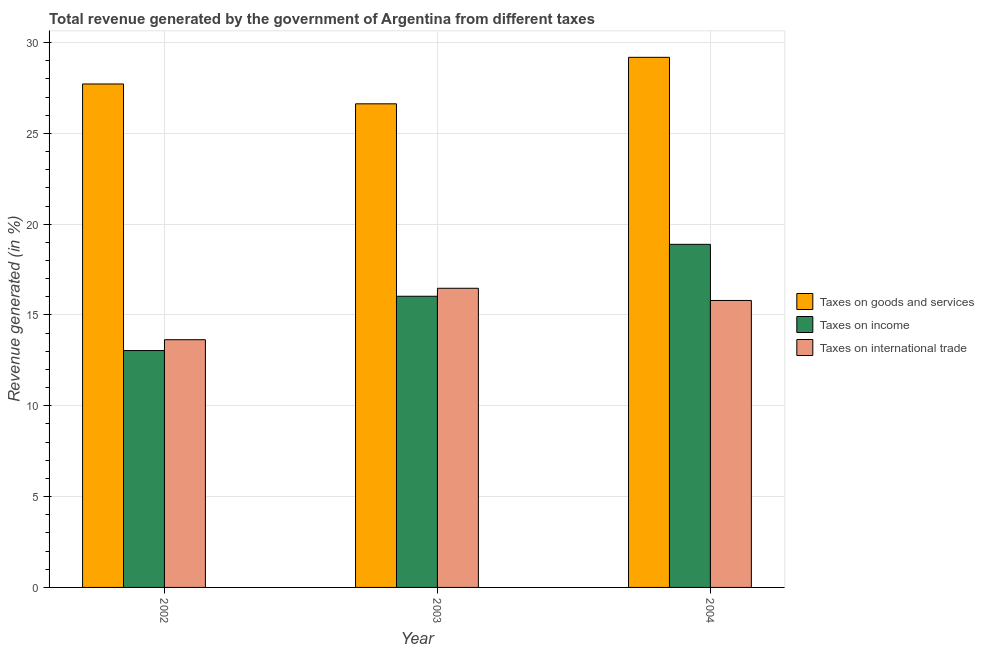How many groups of bars are there?
Keep it short and to the point. 3. What is the percentage of revenue generated by taxes on income in 2003?
Give a very brief answer. 16.03. Across all years, what is the maximum percentage of revenue generated by taxes on goods and services?
Ensure brevity in your answer.  29.19. Across all years, what is the minimum percentage of revenue generated by taxes on goods and services?
Offer a terse response. 26.63. In which year was the percentage of revenue generated by tax on international trade maximum?
Provide a succinct answer. 2003. What is the total percentage of revenue generated by taxes on goods and services in the graph?
Give a very brief answer. 83.53. What is the difference between the percentage of revenue generated by tax on international trade in 2003 and that in 2004?
Make the answer very short. 0.67. What is the difference between the percentage of revenue generated by tax on international trade in 2003 and the percentage of revenue generated by taxes on income in 2002?
Your answer should be very brief. 2.83. What is the average percentage of revenue generated by taxes on goods and services per year?
Provide a succinct answer. 27.84. In how many years, is the percentage of revenue generated by taxes on goods and services greater than 14 %?
Your answer should be compact. 3. What is the ratio of the percentage of revenue generated by taxes on goods and services in 2002 to that in 2003?
Offer a very short reply. 1.04. Is the percentage of revenue generated by taxes on income in 2002 less than that in 2004?
Offer a terse response. Yes. Is the difference between the percentage of revenue generated by taxes on income in 2003 and 2004 greater than the difference between the percentage of revenue generated by tax on international trade in 2003 and 2004?
Your answer should be very brief. No. What is the difference between the highest and the second highest percentage of revenue generated by taxes on goods and services?
Offer a terse response. 1.47. What is the difference between the highest and the lowest percentage of revenue generated by taxes on income?
Your answer should be very brief. 5.85. In how many years, is the percentage of revenue generated by tax on international trade greater than the average percentage of revenue generated by tax on international trade taken over all years?
Ensure brevity in your answer.  2. Is the sum of the percentage of revenue generated by taxes on income in 2002 and 2004 greater than the maximum percentage of revenue generated by taxes on goods and services across all years?
Provide a short and direct response. Yes. What does the 3rd bar from the left in 2004 represents?
Your response must be concise. Taxes on international trade. What does the 3rd bar from the right in 2002 represents?
Give a very brief answer. Taxes on goods and services. Is it the case that in every year, the sum of the percentage of revenue generated by taxes on goods and services and percentage of revenue generated by taxes on income is greater than the percentage of revenue generated by tax on international trade?
Your answer should be very brief. Yes. How many bars are there?
Make the answer very short. 9. Are all the bars in the graph horizontal?
Offer a terse response. No. How many years are there in the graph?
Keep it short and to the point. 3. Are the values on the major ticks of Y-axis written in scientific E-notation?
Give a very brief answer. No. What is the title of the graph?
Ensure brevity in your answer.  Total revenue generated by the government of Argentina from different taxes. What is the label or title of the X-axis?
Ensure brevity in your answer.  Year. What is the label or title of the Y-axis?
Keep it short and to the point. Revenue generated (in %). What is the Revenue generated (in %) in Taxes on goods and services in 2002?
Provide a short and direct response. 27.72. What is the Revenue generated (in %) in Taxes on income in 2002?
Provide a succinct answer. 13.04. What is the Revenue generated (in %) in Taxes on international trade in 2002?
Your response must be concise. 13.64. What is the Revenue generated (in %) in Taxes on goods and services in 2003?
Ensure brevity in your answer.  26.63. What is the Revenue generated (in %) of Taxes on income in 2003?
Offer a very short reply. 16.03. What is the Revenue generated (in %) in Taxes on international trade in 2003?
Your response must be concise. 16.47. What is the Revenue generated (in %) in Taxes on goods and services in 2004?
Your answer should be compact. 29.19. What is the Revenue generated (in %) in Taxes on income in 2004?
Your answer should be very brief. 18.89. What is the Revenue generated (in %) in Taxes on international trade in 2004?
Your response must be concise. 15.8. Across all years, what is the maximum Revenue generated (in %) of Taxes on goods and services?
Your response must be concise. 29.19. Across all years, what is the maximum Revenue generated (in %) of Taxes on income?
Offer a terse response. 18.89. Across all years, what is the maximum Revenue generated (in %) of Taxes on international trade?
Provide a succinct answer. 16.47. Across all years, what is the minimum Revenue generated (in %) in Taxes on goods and services?
Keep it short and to the point. 26.63. Across all years, what is the minimum Revenue generated (in %) in Taxes on income?
Make the answer very short. 13.04. Across all years, what is the minimum Revenue generated (in %) of Taxes on international trade?
Your answer should be compact. 13.64. What is the total Revenue generated (in %) of Taxes on goods and services in the graph?
Your answer should be compact. 83.53. What is the total Revenue generated (in %) in Taxes on income in the graph?
Keep it short and to the point. 47.96. What is the total Revenue generated (in %) of Taxes on international trade in the graph?
Provide a short and direct response. 45.91. What is the difference between the Revenue generated (in %) in Taxes on goods and services in 2002 and that in 2003?
Make the answer very short. 1.09. What is the difference between the Revenue generated (in %) of Taxes on income in 2002 and that in 2003?
Your response must be concise. -2.99. What is the difference between the Revenue generated (in %) of Taxes on international trade in 2002 and that in 2003?
Offer a terse response. -2.83. What is the difference between the Revenue generated (in %) in Taxes on goods and services in 2002 and that in 2004?
Your response must be concise. -1.47. What is the difference between the Revenue generated (in %) of Taxes on income in 2002 and that in 2004?
Your response must be concise. -5.85. What is the difference between the Revenue generated (in %) in Taxes on international trade in 2002 and that in 2004?
Your response must be concise. -2.16. What is the difference between the Revenue generated (in %) in Taxes on goods and services in 2003 and that in 2004?
Keep it short and to the point. -2.56. What is the difference between the Revenue generated (in %) in Taxes on income in 2003 and that in 2004?
Keep it short and to the point. -2.86. What is the difference between the Revenue generated (in %) of Taxes on international trade in 2003 and that in 2004?
Keep it short and to the point. 0.67. What is the difference between the Revenue generated (in %) in Taxes on goods and services in 2002 and the Revenue generated (in %) in Taxes on income in 2003?
Give a very brief answer. 11.69. What is the difference between the Revenue generated (in %) of Taxes on goods and services in 2002 and the Revenue generated (in %) of Taxes on international trade in 2003?
Your answer should be very brief. 11.25. What is the difference between the Revenue generated (in %) in Taxes on income in 2002 and the Revenue generated (in %) in Taxes on international trade in 2003?
Give a very brief answer. -3.43. What is the difference between the Revenue generated (in %) in Taxes on goods and services in 2002 and the Revenue generated (in %) in Taxes on income in 2004?
Keep it short and to the point. 8.83. What is the difference between the Revenue generated (in %) of Taxes on goods and services in 2002 and the Revenue generated (in %) of Taxes on international trade in 2004?
Ensure brevity in your answer.  11.92. What is the difference between the Revenue generated (in %) in Taxes on income in 2002 and the Revenue generated (in %) in Taxes on international trade in 2004?
Your answer should be compact. -2.76. What is the difference between the Revenue generated (in %) in Taxes on goods and services in 2003 and the Revenue generated (in %) in Taxes on income in 2004?
Your response must be concise. 7.74. What is the difference between the Revenue generated (in %) in Taxes on goods and services in 2003 and the Revenue generated (in %) in Taxes on international trade in 2004?
Offer a terse response. 10.83. What is the difference between the Revenue generated (in %) in Taxes on income in 2003 and the Revenue generated (in %) in Taxes on international trade in 2004?
Your answer should be compact. 0.23. What is the average Revenue generated (in %) in Taxes on goods and services per year?
Your response must be concise. 27.84. What is the average Revenue generated (in %) in Taxes on income per year?
Make the answer very short. 15.99. What is the average Revenue generated (in %) in Taxes on international trade per year?
Your response must be concise. 15.3. In the year 2002, what is the difference between the Revenue generated (in %) of Taxes on goods and services and Revenue generated (in %) of Taxes on income?
Provide a short and direct response. 14.68. In the year 2002, what is the difference between the Revenue generated (in %) in Taxes on goods and services and Revenue generated (in %) in Taxes on international trade?
Your answer should be compact. 14.08. In the year 2002, what is the difference between the Revenue generated (in %) of Taxes on income and Revenue generated (in %) of Taxes on international trade?
Provide a succinct answer. -0.6. In the year 2003, what is the difference between the Revenue generated (in %) of Taxes on goods and services and Revenue generated (in %) of Taxes on income?
Your answer should be very brief. 10.59. In the year 2003, what is the difference between the Revenue generated (in %) of Taxes on goods and services and Revenue generated (in %) of Taxes on international trade?
Make the answer very short. 10.16. In the year 2003, what is the difference between the Revenue generated (in %) in Taxes on income and Revenue generated (in %) in Taxes on international trade?
Ensure brevity in your answer.  -0.44. In the year 2004, what is the difference between the Revenue generated (in %) in Taxes on goods and services and Revenue generated (in %) in Taxes on income?
Ensure brevity in your answer.  10.3. In the year 2004, what is the difference between the Revenue generated (in %) in Taxes on goods and services and Revenue generated (in %) in Taxes on international trade?
Offer a terse response. 13.39. In the year 2004, what is the difference between the Revenue generated (in %) in Taxes on income and Revenue generated (in %) in Taxes on international trade?
Your answer should be compact. 3.09. What is the ratio of the Revenue generated (in %) of Taxes on goods and services in 2002 to that in 2003?
Offer a terse response. 1.04. What is the ratio of the Revenue generated (in %) of Taxes on income in 2002 to that in 2003?
Provide a succinct answer. 0.81. What is the ratio of the Revenue generated (in %) in Taxes on international trade in 2002 to that in 2003?
Provide a succinct answer. 0.83. What is the ratio of the Revenue generated (in %) in Taxes on goods and services in 2002 to that in 2004?
Ensure brevity in your answer.  0.95. What is the ratio of the Revenue generated (in %) in Taxes on income in 2002 to that in 2004?
Offer a very short reply. 0.69. What is the ratio of the Revenue generated (in %) of Taxes on international trade in 2002 to that in 2004?
Provide a succinct answer. 0.86. What is the ratio of the Revenue generated (in %) in Taxes on goods and services in 2003 to that in 2004?
Your answer should be compact. 0.91. What is the ratio of the Revenue generated (in %) in Taxes on income in 2003 to that in 2004?
Offer a very short reply. 0.85. What is the ratio of the Revenue generated (in %) of Taxes on international trade in 2003 to that in 2004?
Offer a very short reply. 1.04. What is the difference between the highest and the second highest Revenue generated (in %) in Taxes on goods and services?
Make the answer very short. 1.47. What is the difference between the highest and the second highest Revenue generated (in %) in Taxes on income?
Make the answer very short. 2.86. What is the difference between the highest and the second highest Revenue generated (in %) of Taxes on international trade?
Give a very brief answer. 0.67. What is the difference between the highest and the lowest Revenue generated (in %) of Taxes on goods and services?
Your answer should be very brief. 2.56. What is the difference between the highest and the lowest Revenue generated (in %) in Taxes on income?
Offer a very short reply. 5.85. What is the difference between the highest and the lowest Revenue generated (in %) of Taxes on international trade?
Make the answer very short. 2.83. 